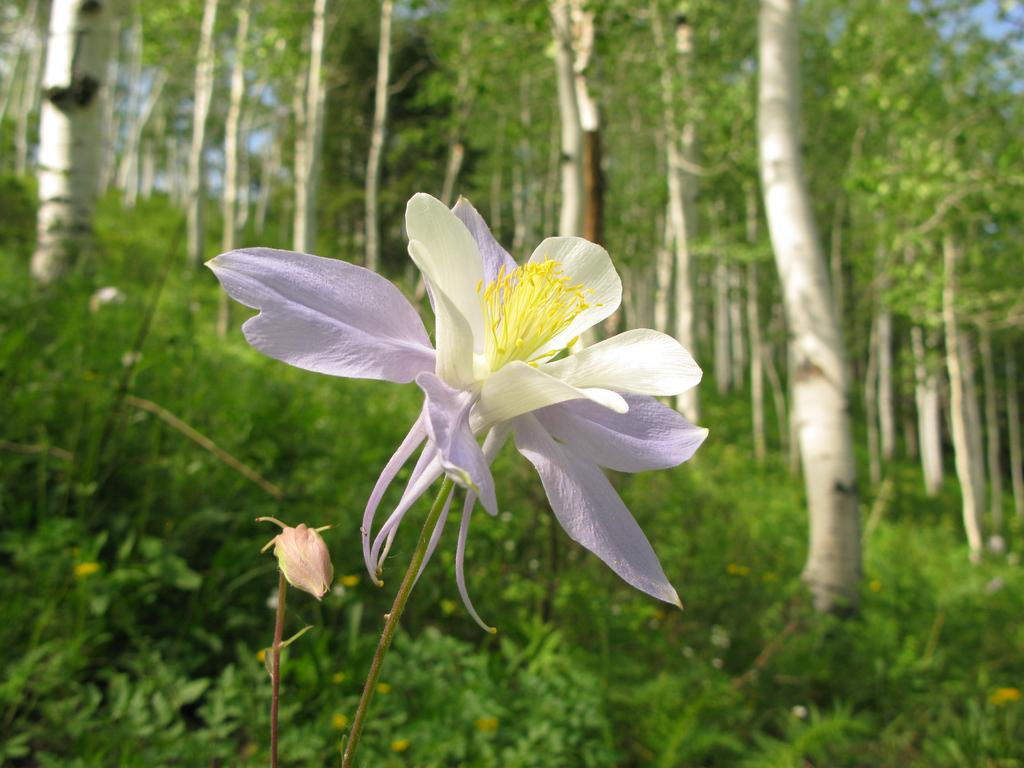What is the main subject in the center of the image? There is a flower in the center of the image, and there is also a bud. What can be seen in the background of the image? There are trees in the background of the image. What type of church can be seen in the image? There is no church present in the image; it features a flower and a bud with trees in the background. 